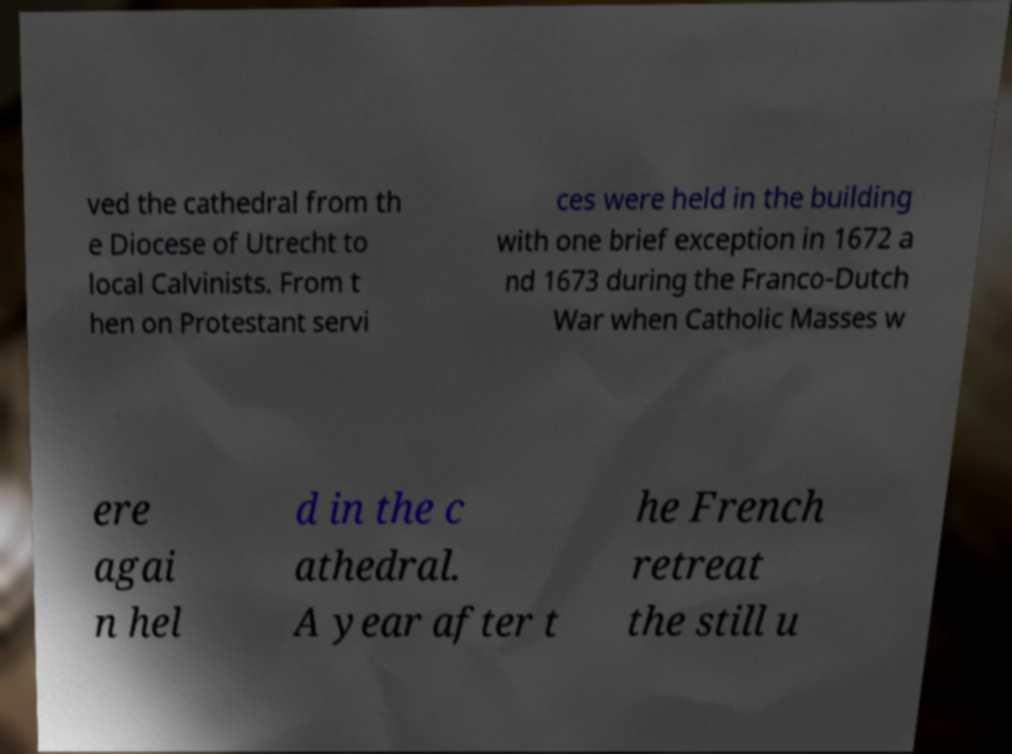Can you read and provide the text displayed in the image?This photo seems to have some interesting text. Can you extract and type it out for me? ved the cathedral from th e Diocese of Utrecht to local Calvinists. From t hen on Protestant servi ces were held in the building with one brief exception in 1672 a nd 1673 during the Franco-Dutch War when Catholic Masses w ere agai n hel d in the c athedral. A year after t he French retreat the still u 